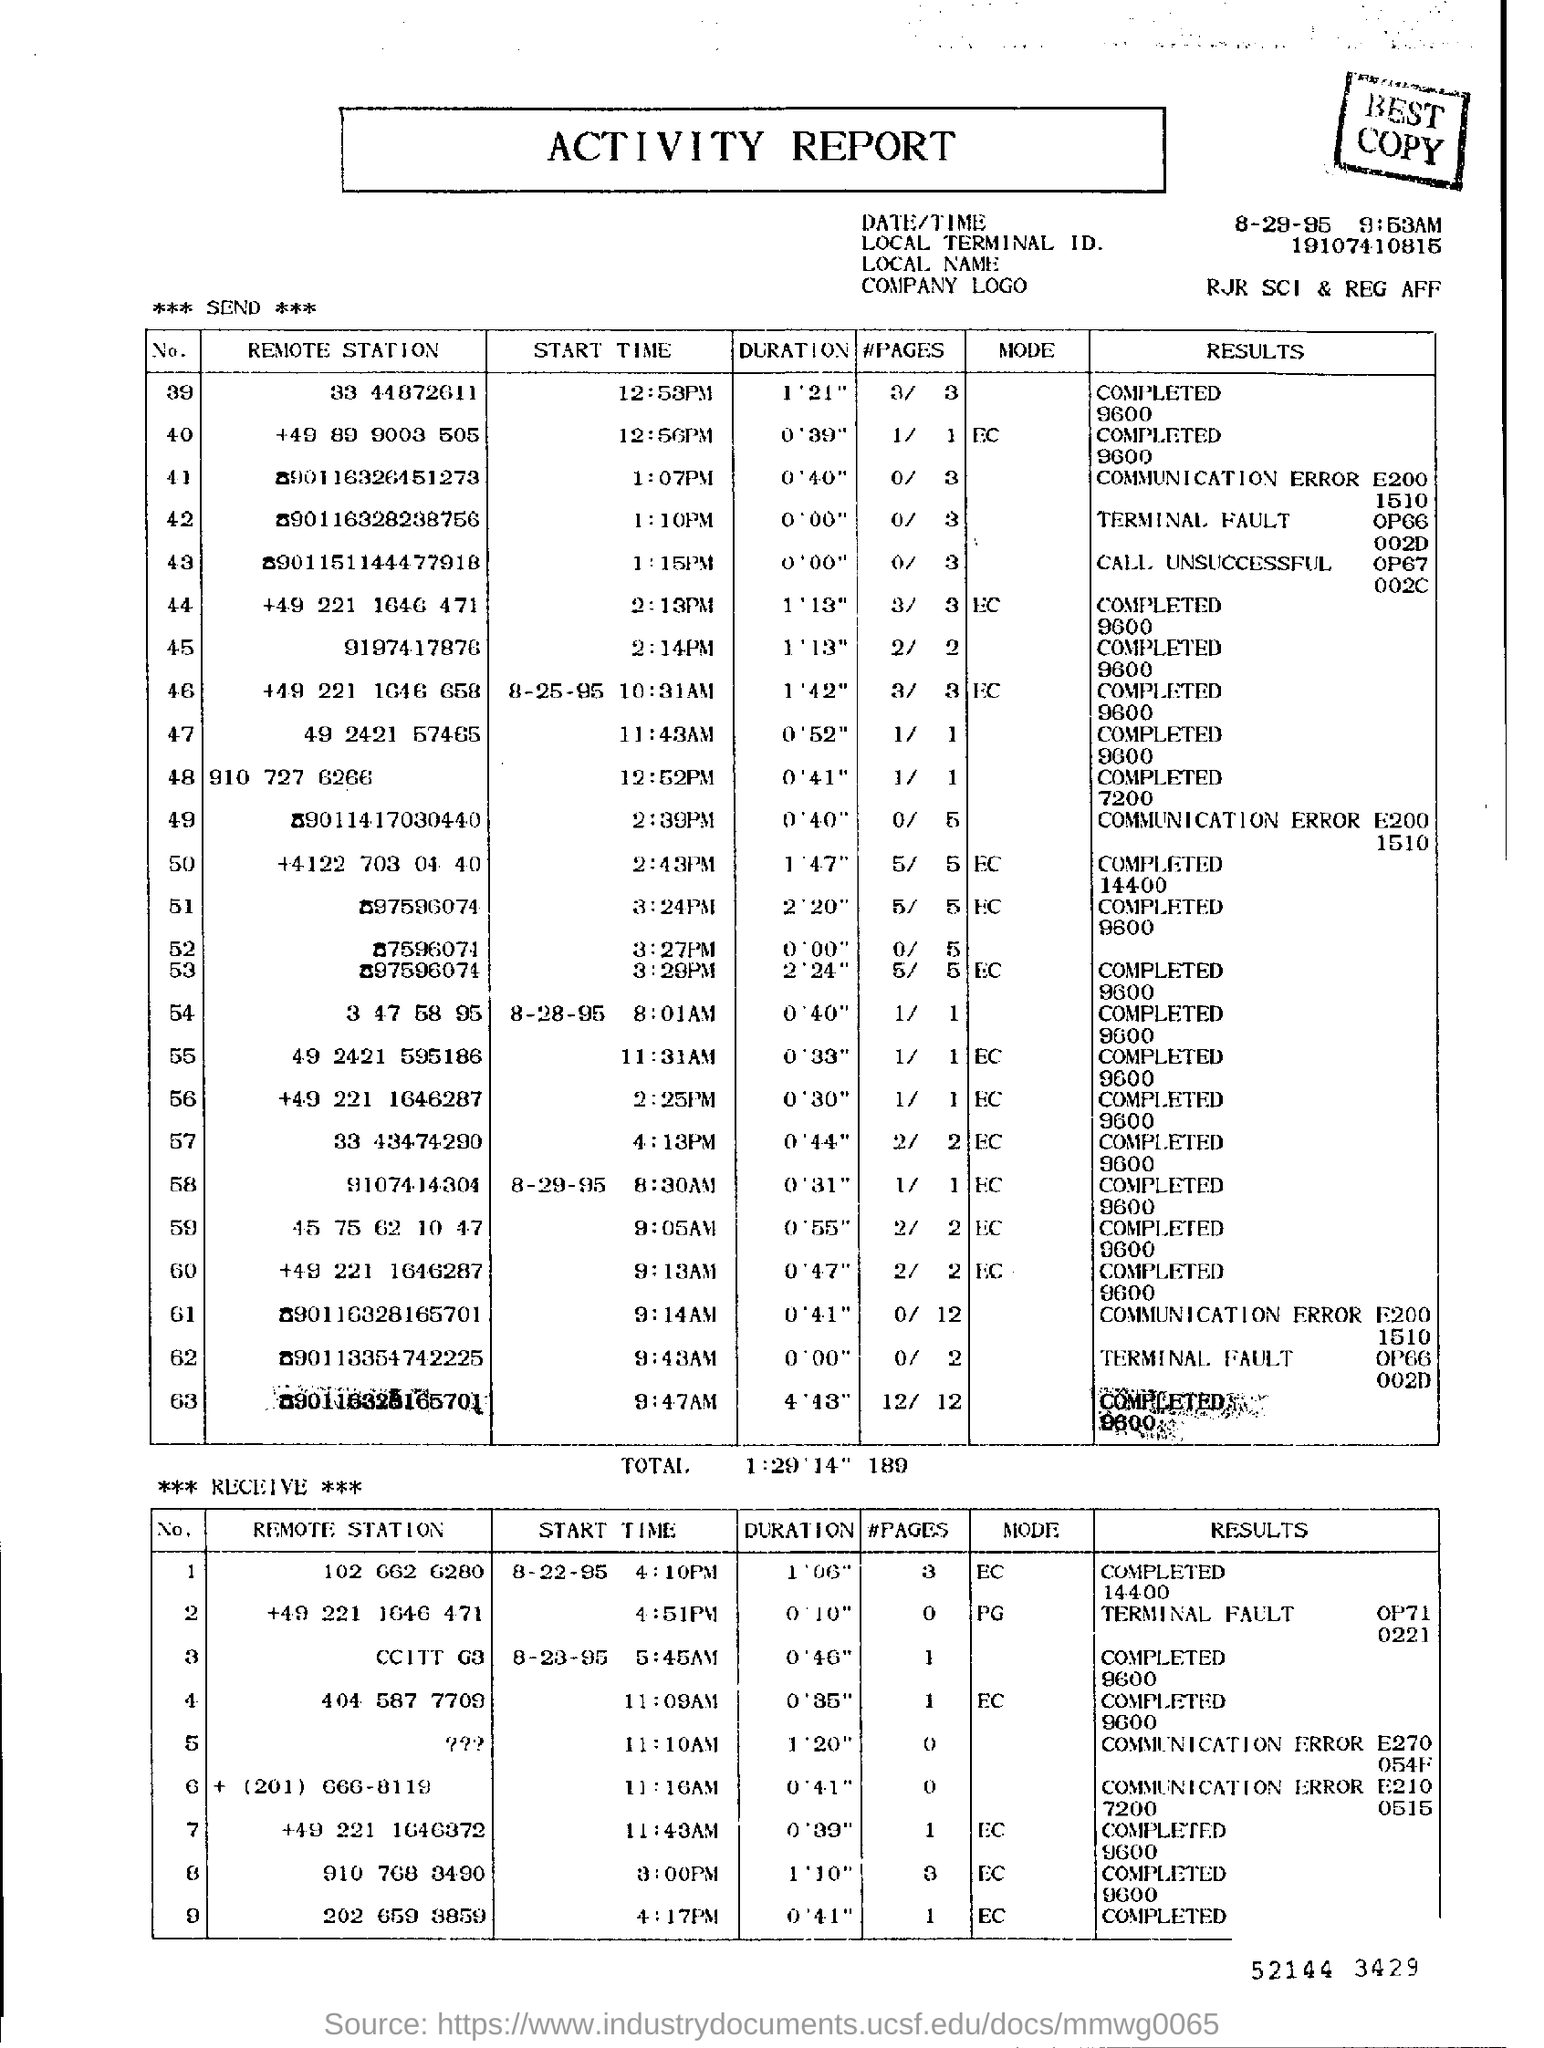What kind of document is this?
Offer a terse response. ACTIVITY REPORT. What is the Local Terminal ID mentioned in the report?
Provide a short and direct response. 19107410815. 